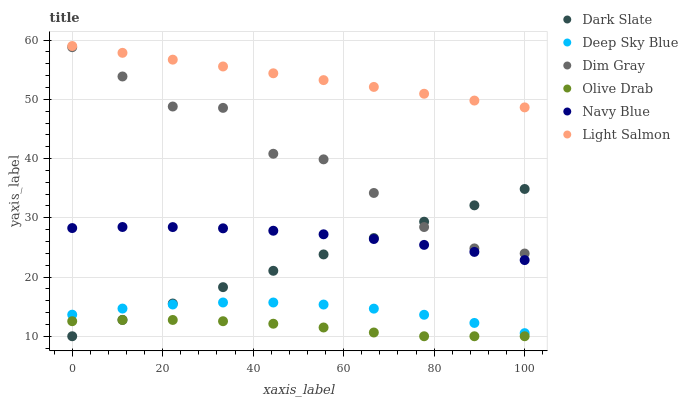Does Olive Drab have the minimum area under the curve?
Answer yes or no. Yes. Does Light Salmon have the maximum area under the curve?
Answer yes or no. Yes. Does Dim Gray have the minimum area under the curve?
Answer yes or no. No. Does Dim Gray have the maximum area under the curve?
Answer yes or no. No. Is Light Salmon the smoothest?
Answer yes or no. Yes. Is Dim Gray the roughest?
Answer yes or no. Yes. Is Navy Blue the smoothest?
Answer yes or no. No. Is Navy Blue the roughest?
Answer yes or no. No. Does Dark Slate have the lowest value?
Answer yes or no. Yes. Does Dim Gray have the lowest value?
Answer yes or no. No. Does Light Salmon have the highest value?
Answer yes or no. Yes. Does Dim Gray have the highest value?
Answer yes or no. No. Is Olive Drab less than Light Salmon?
Answer yes or no. Yes. Is Light Salmon greater than Dim Gray?
Answer yes or no. Yes. Does Dark Slate intersect Navy Blue?
Answer yes or no. Yes. Is Dark Slate less than Navy Blue?
Answer yes or no. No. Is Dark Slate greater than Navy Blue?
Answer yes or no. No. Does Olive Drab intersect Light Salmon?
Answer yes or no. No. 